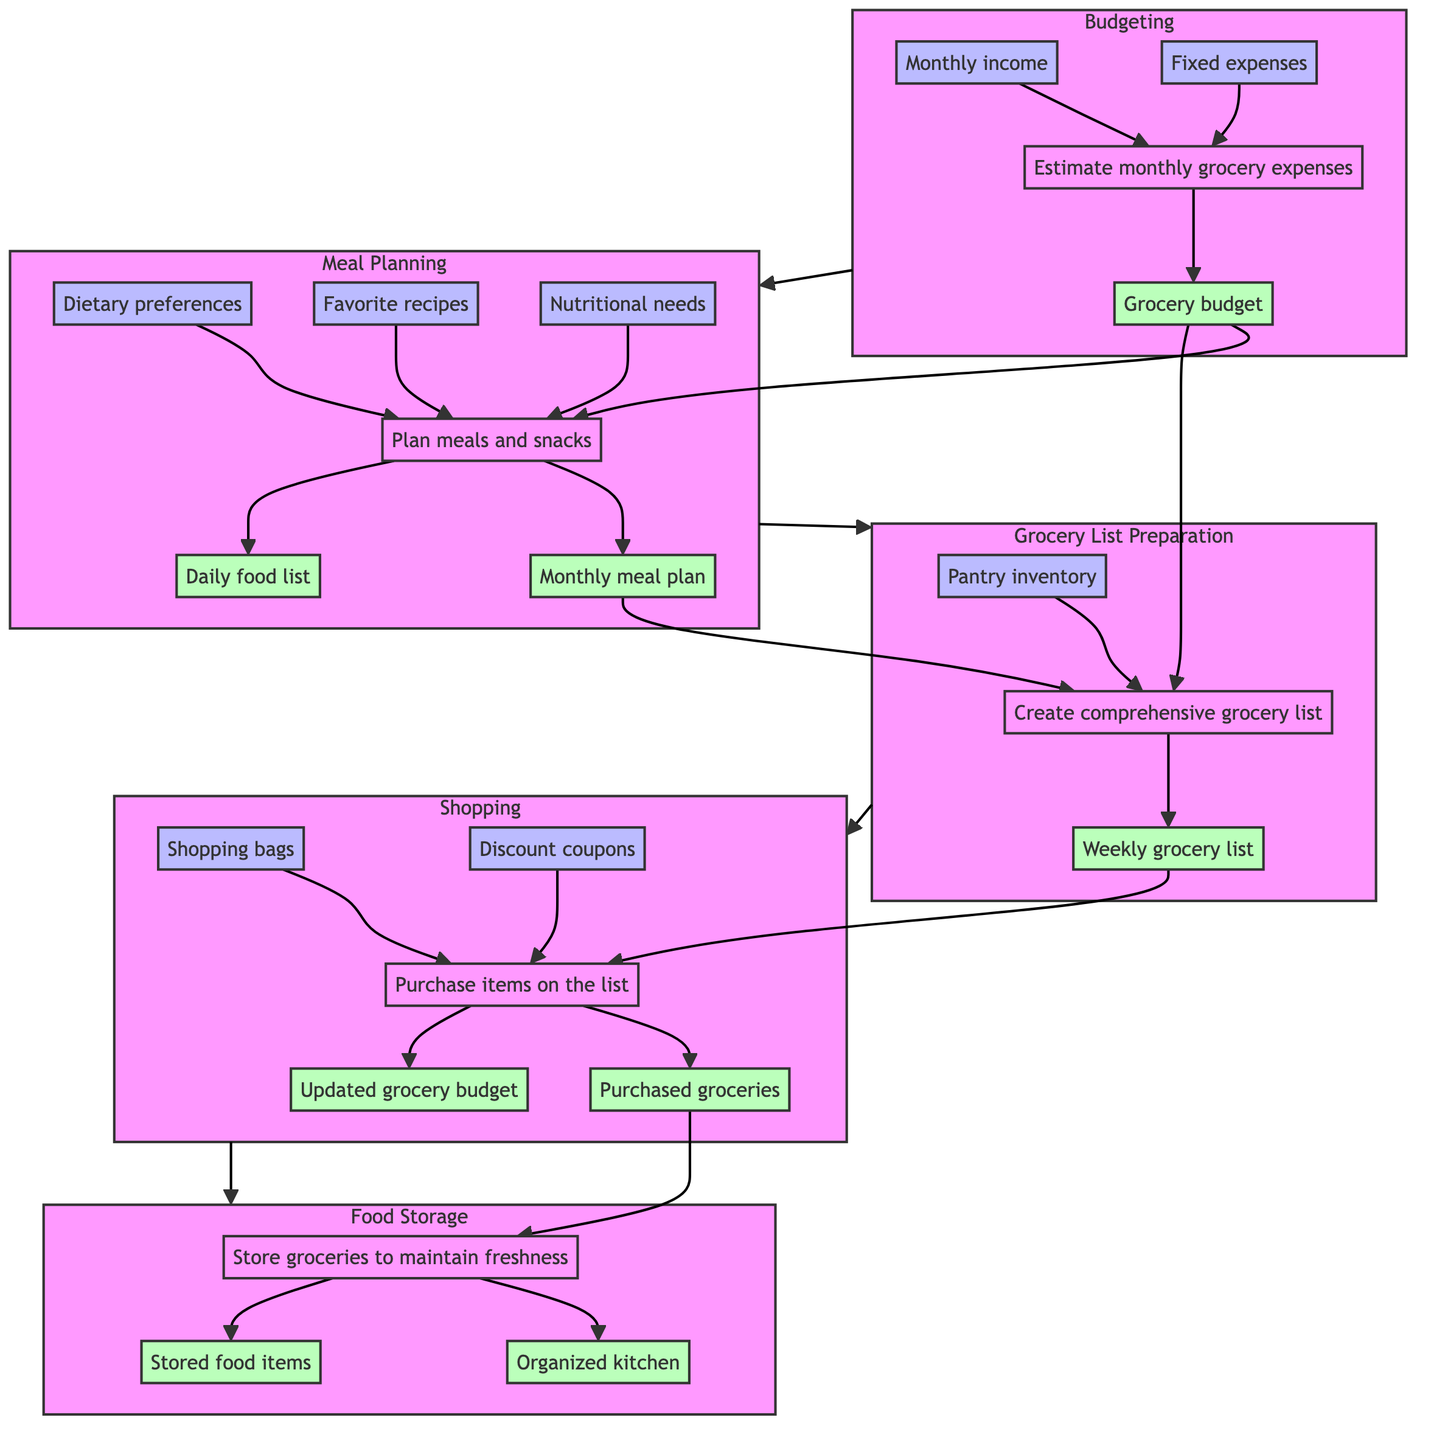What is the first step in the monthly grocery shopping process? The diagram indicates that the first step is "Budgeting," which is involved in estimating monthly grocery expenses based on the available budget.
Answer: Budgeting How many outputs does the "Meal Planning" step produce? According to the diagram, the "Meal Planning" step generates two outputs: "Monthly meal plan" and "Daily food list."
Answer: 2 What is the primary input for the "Grocery List Preparation" step? The diagram specifies that "Monthly meal plan" is an input for the "Grocery List Preparation" step, alongside "Pantry inventory" and "Grocery budget."
Answer: Monthly meal plan Which step involves storing groceries to maintain freshness? The diagram shows that the last step, labeled "Food Storage," is responsible for storing groceries to maintain freshness.
Answer: Food Storage How does the output of the "Shopping" step relate to the subsequent step? The output of the "Shopping" step includes "Purchased groceries" and "Updated grocery budget," which becomes the input for the "Food Storage" step that follows it.
Answer: Purchased groceries, Updated grocery budget What is the relationship between budgeting and meal planning? "Budgeting" provides the output "Grocery budget" that serves as an input for the "Meal Planning" step, linking the two stages together in the process.
Answer: Grocery budget How many total steps are there in the entire monthly grocery shopping process? The diagram outlines five distinct steps in the monthly grocery shopping process, from "Budgeting" to "Food Storage."
Answer: 5 What do "Purchased groceries" and "Updated grocery budget" have in common? Both "Purchased groceries" and "Updated grocery budget" are outputs from the "Shopping" step that feed into the "Food Storage" step, indicating a direct flow of outcomes from one stage to the next.
Answer: Outputs from Shopping Which step directly depends on "Pantry inventory"? The diagram shows that "Grocery List Preparation" directly depends on "Pantry inventory" as one of its inputs, among others.
Answer: Grocery List Preparation 